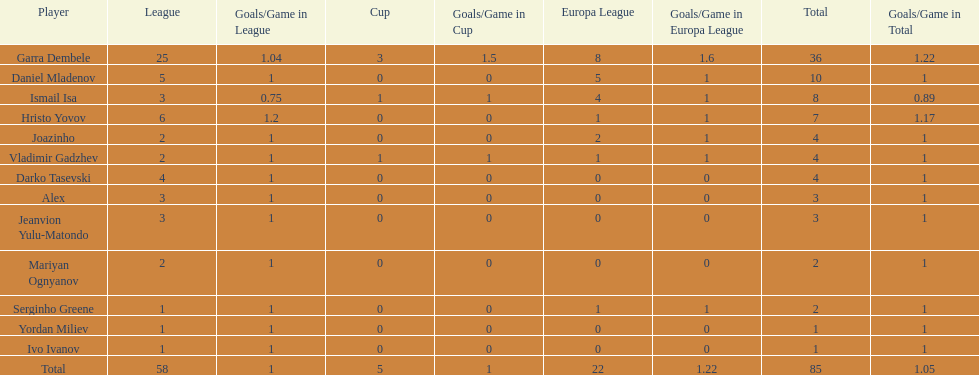Write the full table. {'header': ['Player', 'League', 'Goals/Game in League', 'Cup', 'Goals/Game in Cup', 'Europa League', 'Goals/Game in Europa League', 'Total', 'Goals/Game in Total'], 'rows': [['Garra Dembele', '25', '1.04', '3', '1.5', '8', '1.6', '36', '1.22'], ['Daniel Mladenov', '5', '1', '0', '0', '5', '1', '10', '1'], ['Ismail Isa', '3', '0.75', '1', '1', '4', '1', '8', '0.89'], ['Hristo Yovov', '6', '1.2', '0', '0', '1', '1', '7', '1.17'], ['Joazinho', '2', '1', '0', '0', '2', '1', '4', '1'], ['Vladimir Gadzhev', '2', '1', '1', '1', '1', '1', '4', '1'], ['Darko Tasevski', '4', '1', '0', '0', '0', '0', '4', '1'], ['Alex', '3', '1', '0', '0', '0', '0', '3', '1'], ['Jeanvion Yulu-Matondo', '3', '1', '0', '0', '0', '0', '3', '1'], ['Mariyan Ognyanov', '2', '1', '0', '0', '0', '0', '2', '1'], ['Serginho Greene', '1', '1', '0', '0', '1', '1', '2', '1'], ['Yordan Miliev', '1', '1', '0', '0', '0', '0', '1', '1'], ['Ivo Ivanov', '1', '1', '0', '0', '0', '0', '1', '1'], ['Total', '58', '1', '5', '1', '22', '1.22', '85', '1.05']]} Which total is higher, the europa league total or the league total? League. 